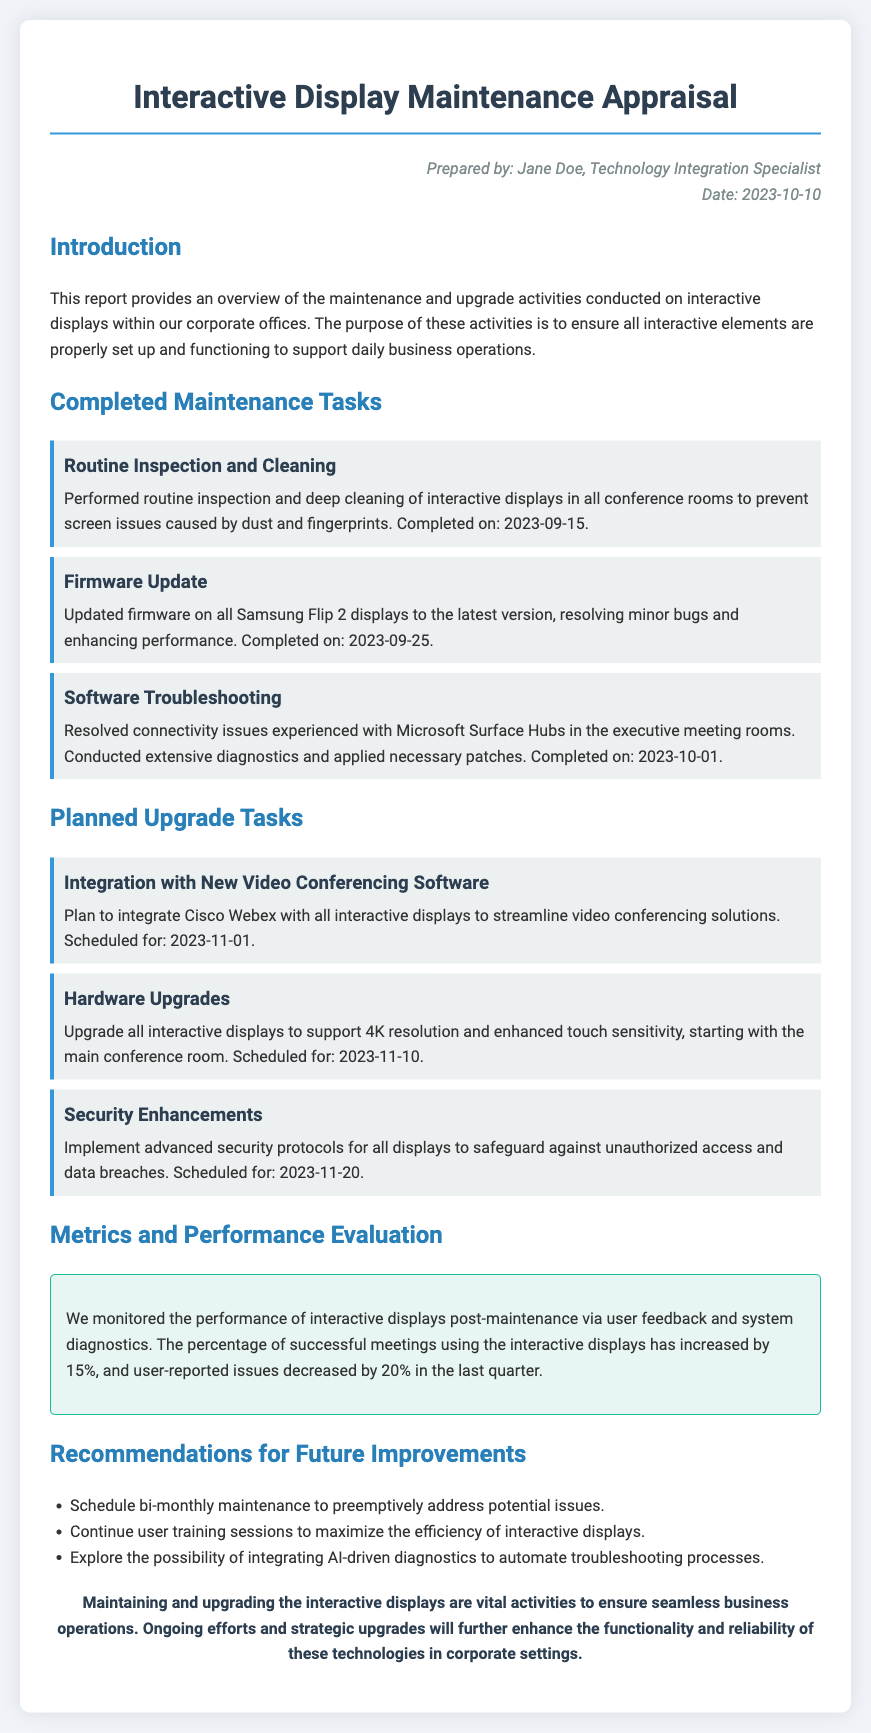What is the date of the report? The date of the report is explicitly stated in the document, which is provided in the author's details section.
Answer: 2023-10-10 Who prepared the report? The author section at the top provides the name of the individual who prepared the report.
Answer: Jane Doe What is the scheduled date for the integration with new video conferencing software? The planned upgrade tasks section specifies the date for the integration of Cisco Webex with all displays.
Answer: 2023-11-01 How much has the percentage of successful meetings using the displays increased? The metrics and performance evaluation section notes the percentage increase in successful meetings as compared to the previous quarter.
Answer: 15% What task was completed on 2023-09-25? The completed maintenance tasks section lists the specific task that was finished on this date, which is noted clearly.
Answer: Firmware Update What is one recommendation for future improvements mentioned in the document? The recommendations section includes several proposals for improving the maintenance and operation of interactive displays.
Answer: Schedule bi-monthly maintenance What percentage of user-reported issues decreased in the last quarter? The metrics and performance evaluation section highlights the decrease in reported issues, providing a specific figure.
Answer: 20% What is the purpose of the maintenance and upgrade activities mentioned in the introduction? The introduction section states the overall objective of conducting these activities, which is directly mentioned.
Answer: Ensure all interactive elements are properly set up and functioning 